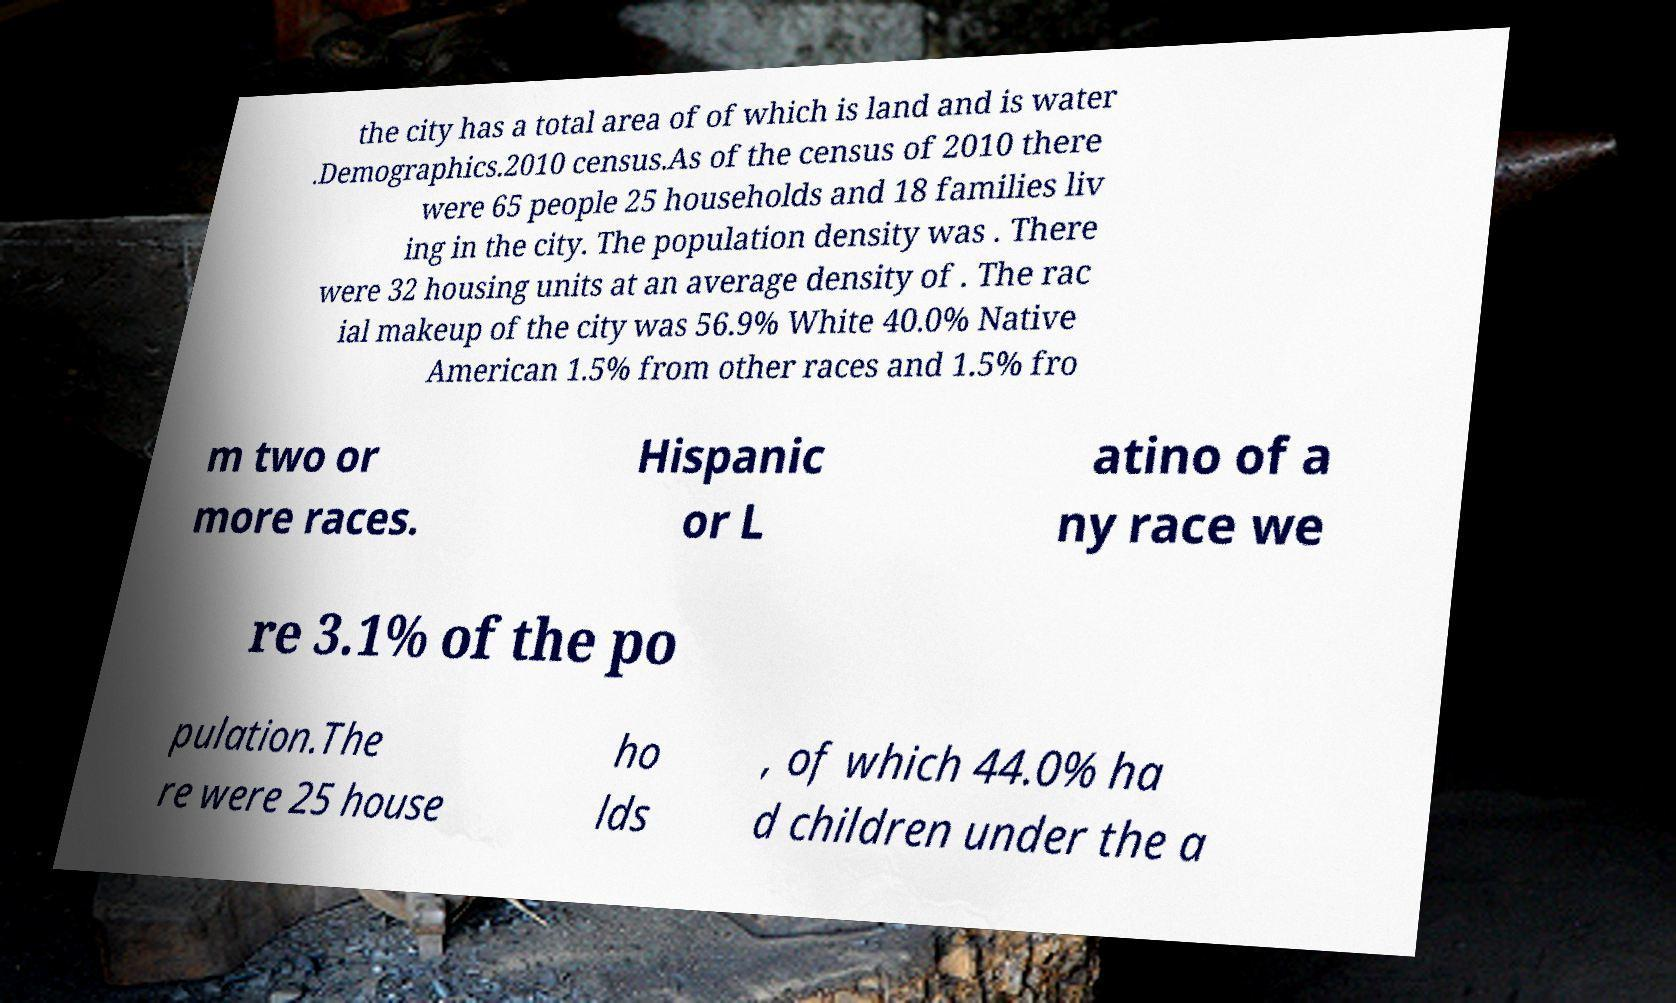Could you extract and type out the text from this image? the city has a total area of of which is land and is water .Demographics.2010 census.As of the census of 2010 there were 65 people 25 households and 18 families liv ing in the city. The population density was . There were 32 housing units at an average density of . The rac ial makeup of the city was 56.9% White 40.0% Native American 1.5% from other races and 1.5% fro m two or more races. Hispanic or L atino of a ny race we re 3.1% of the po pulation.The re were 25 house ho lds , of which 44.0% ha d children under the a 